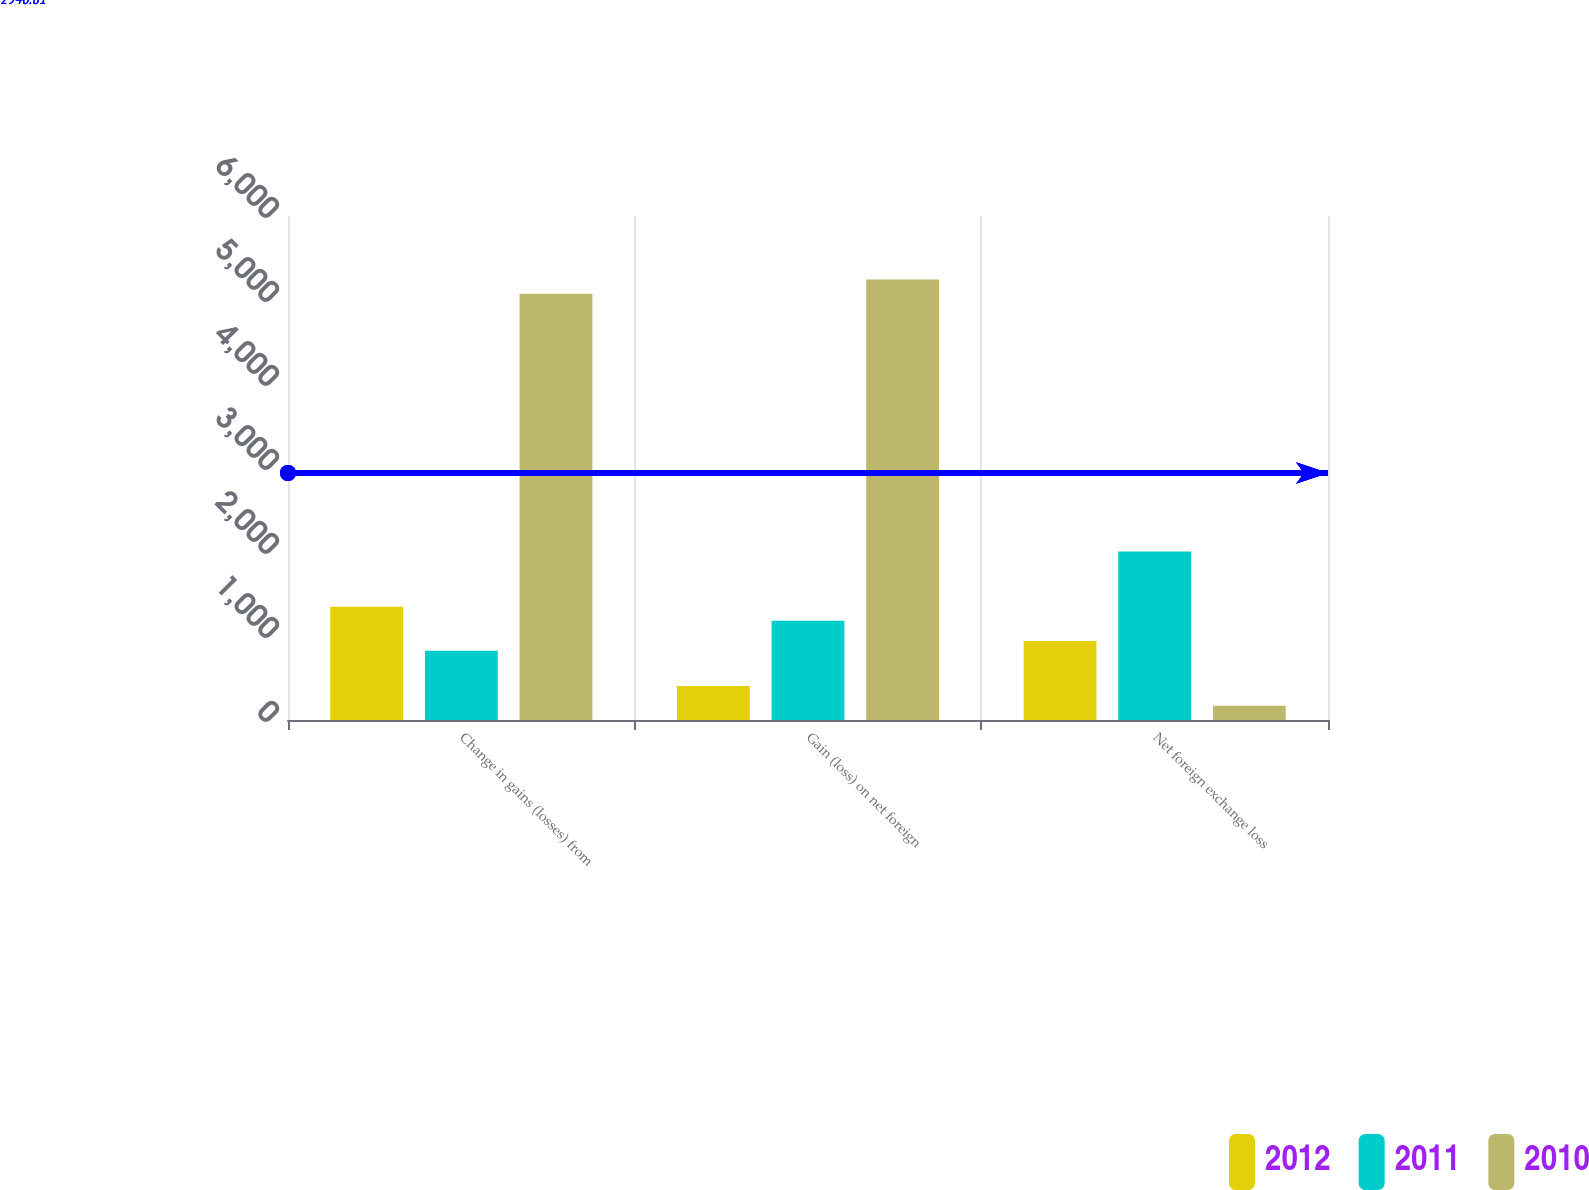Convert chart to OTSL. <chart><loc_0><loc_0><loc_500><loc_500><stacked_bar_chart><ecel><fcel>Change in gains (losses) from<fcel>Gain (loss) on net foreign<fcel>Net foreign exchange loss<nl><fcel>2012<fcel>1347<fcel>406<fcel>941<nl><fcel>2011<fcel>825<fcel>1181<fcel>2006<nl><fcel>2010<fcel>5074<fcel>5243<fcel>169<nl></chart> 